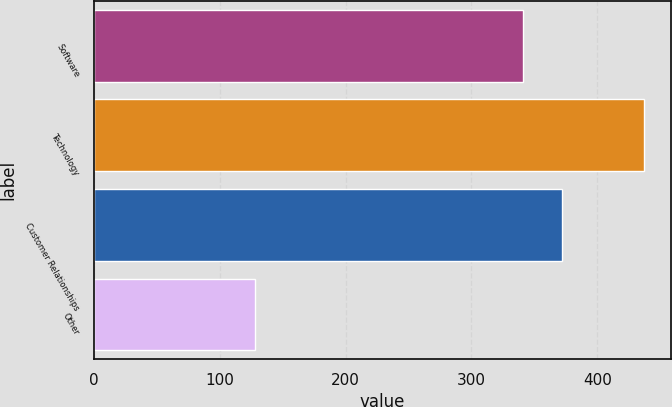Convert chart to OTSL. <chart><loc_0><loc_0><loc_500><loc_500><bar_chart><fcel>Software<fcel>Technology<fcel>Customer Relationships<fcel>Other<nl><fcel>341<fcel>437<fcel>371.9<fcel>128<nl></chart> 